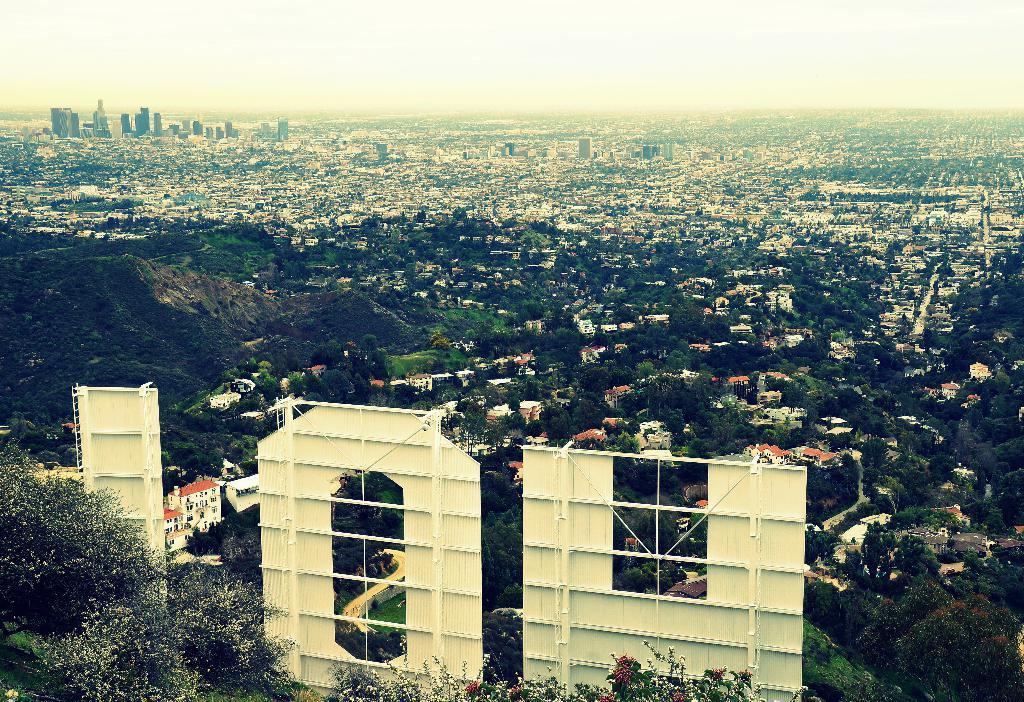In one or two sentences, can you explain what this image depicts? This is an image of a street view. In this image there are a few metal sheets, trees, buildings and in the background there is the sky. 